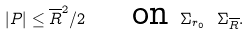Convert formula to latex. <formula><loc_0><loc_0><loc_500><loc_500>| P | \leq \overline { R } ^ { 2 } / 2 \quad \text { on } \Sigma _ { r _ { 0 } } \ \Sigma _ { \overline { R } } .</formula> 